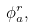Convert formula to latex. <formula><loc_0><loc_0><loc_500><loc_500>\phi _ { a } ^ { r } ,</formula> 